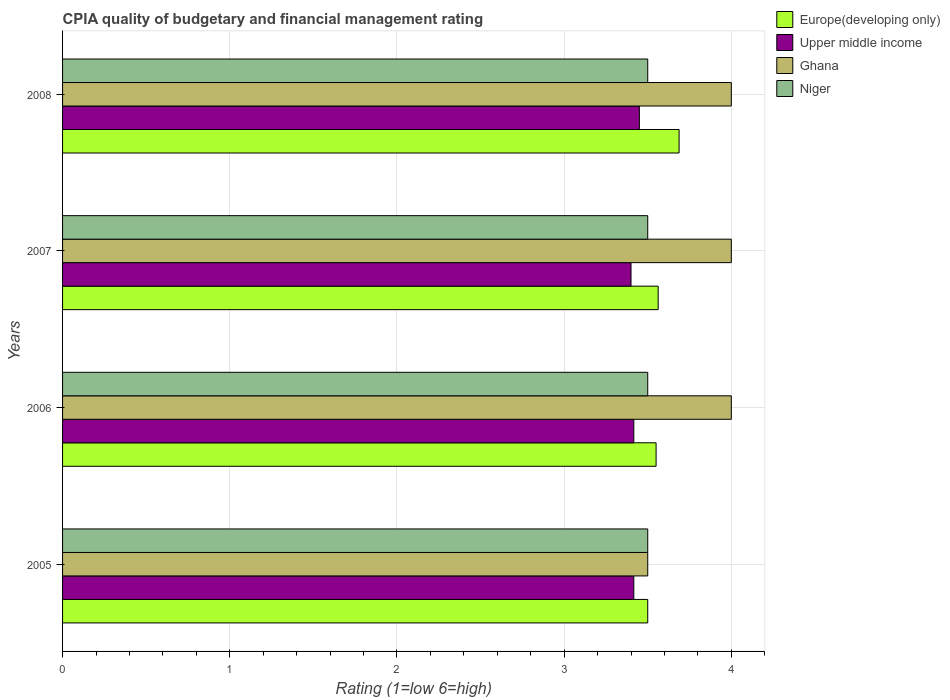How many groups of bars are there?
Give a very brief answer. 4. Are the number of bars on each tick of the Y-axis equal?
Provide a succinct answer. Yes. How many bars are there on the 1st tick from the bottom?
Offer a very short reply. 4. In how many cases, is the number of bars for a given year not equal to the number of legend labels?
Ensure brevity in your answer.  0. What is the CPIA rating in Niger in 2006?
Your response must be concise. 3.5. Across all years, what is the minimum CPIA rating in Upper middle income?
Your answer should be very brief. 3.4. What is the total CPIA rating in Upper middle income in the graph?
Provide a short and direct response. 13.68. What is the difference between the CPIA rating in Ghana in 2006 and the CPIA rating in Upper middle income in 2007?
Your answer should be compact. 0.6. In the year 2007, what is the difference between the CPIA rating in Niger and CPIA rating in Upper middle income?
Your answer should be compact. 0.1. In how many years, is the CPIA rating in Niger greater than 3 ?
Your response must be concise. 4. What is the ratio of the CPIA rating in Europe(developing only) in 2006 to that in 2007?
Ensure brevity in your answer.  1. Is the CPIA rating in Ghana in 2005 less than that in 2008?
Provide a short and direct response. Yes. Is the difference between the CPIA rating in Niger in 2005 and 2008 greater than the difference between the CPIA rating in Upper middle income in 2005 and 2008?
Give a very brief answer. Yes. What is the difference between the highest and the second highest CPIA rating in Upper middle income?
Give a very brief answer. 0.03. What is the difference between the highest and the lowest CPIA rating in Europe(developing only)?
Offer a terse response. 0.19. What does the 4th bar from the top in 2006 represents?
Provide a succinct answer. Europe(developing only). What does the 1st bar from the bottom in 2007 represents?
Your answer should be very brief. Europe(developing only). How many years are there in the graph?
Make the answer very short. 4. What is the difference between two consecutive major ticks on the X-axis?
Provide a succinct answer. 1. Are the values on the major ticks of X-axis written in scientific E-notation?
Your answer should be very brief. No. Does the graph contain grids?
Provide a succinct answer. Yes. Where does the legend appear in the graph?
Provide a short and direct response. Top right. How many legend labels are there?
Offer a terse response. 4. What is the title of the graph?
Provide a succinct answer. CPIA quality of budgetary and financial management rating. What is the Rating (1=low 6=high) in Europe(developing only) in 2005?
Your answer should be compact. 3.5. What is the Rating (1=low 6=high) of Upper middle income in 2005?
Your response must be concise. 3.42. What is the Rating (1=low 6=high) of Europe(developing only) in 2006?
Give a very brief answer. 3.55. What is the Rating (1=low 6=high) of Upper middle income in 2006?
Ensure brevity in your answer.  3.42. What is the Rating (1=low 6=high) of Niger in 2006?
Keep it short and to the point. 3.5. What is the Rating (1=low 6=high) in Europe(developing only) in 2007?
Your response must be concise. 3.56. What is the Rating (1=low 6=high) of Upper middle income in 2007?
Offer a very short reply. 3.4. What is the Rating (1=low 6=high) of Ghana in 2007?
Provide a short and direct response. 4. What is the Rating (1=low 6=high) in Niger in 2007?
Make the answer very short. 3.5. What is the Rating (1=low 6=high) of Europe(developing only) in 2008?
Your response must be concise. 3.69. What is the Rating (1=low 6=high) of Upper middle income in 2008?
Offer a terse response. 3.45. What is the Rating (1=low 6=high) of Ghana in 2008?
Keep it short and to the point. 4. Across all years, what is the maximum Rating (1=low 6=high) in Europe(developing only)?
Your response must be concise. 3.69. Across all years, what is the maximum Rating (1=low 6=high) of Upper middle income?
Offer a very short reply. 3.45. Across all years, what is the minimum Rating (1=low 6=high) of Europe(developing only)?
Offer a terse response. 3.5. Across all years, what is the minimum Rating (1=low 6=high) in Upper middle income?
Offer a very short reply. 3.4. What is the total Rating (1=low 6=high) in Upper middle income in the graph?
Ensure brevity in your answer.  13.68. What is the total Rating (1=low 6=high) of Ghana in the graph?
Provide a succinct answer. 15.5. What is the difference between the Rating (1=low 6=high) of Europe(developing only) in 2005 and that in 2006?
Your answer should be very brief. -0.05. What is the difference between the Rating (1=low 6=high) of Europe(developing only) in 2005 and that in 2007?
Ensure brevity in your answer.  -0.06. What is the difference between the Rating (1=low 6=high) in Upper middle income in 2005 and that in 2007?
Offer a terse response. 0.02. What is the difference between the Rating (1=low 6=high) of Ghana in 2005 and that in 2007?
Keep it short and to the point. -0.5. What is the difference between the Rating (1=low 6=high) in Europe(developing only) in 2005 and that in 2008?
Offer a terse response. -0.19. What is the difference between the Rating (1=low 6=high) in Upper middle income in 2005 and that in 2008?
Your answer should be very brief. -0.03. What is the difference between the Rating (1=low 6=high) in Ghana in 2005 and that in 2008?
Make the answer very short. -0.5. What is the difference between the Rating (1=low 6=high) in Niger in 2005 and that in 2008?
Make the answer very short. 0. What is the difference between the Rating (1=low 6=high) in Europe(developing only) in 2006 and that in 2007?
Your answer should be very brief. -0.01. What is the difference between the Rating (1=low 6=high) of Upper middle income in 2006 and that in 2007?
Your answer should be compact. 0.02. What is the difference between the Rating (1=low 6=high) of Ghana in 2006 and that in 2007?
Make the answer very short. 0. What is the difference between the Rating (1=low 6=high) in Europe(developing only) in 2006 and that in 2008?
Make the answer very short. -0.14. What is the difference between the Rating (1=low 6=high) in Upper middle income in 2006 and that in 2008?
Keep it short and to the point. -0.03. What is the difference between the Rating (1=low 6=high) of Niger in 2006 and that in 2008?
Offer a terse response. 0. What is the difference between the Rating (1=low 6=high) of Europe(developing only) in 2007 and that in 2008?
Offer a very short reply. -0.12. What is the difference between the Rating (1=low 6=high) of Ghana in 2007 and that in 2008?
Give a very brief answer. 0. What is the difference between the Rating (1=low 6=high) in Europe(developing only) in 2005 and the Rating (1=low 6=high) in Upper middle income in 2006?
Your response must be concise. 0.08. What is the difference between the Rating (1=low 6=high) in Europe(developing only) in 2005 and the Rating (1=low 6=high) in Ghana in 2006?
Your answer should be very brief. -0.5. What is the difference between the Rating (1=low 6=high) of Upper middle income in 2005 and the Rating (1=low 6=high) of Ghana in 2006?
Ensure brevity in your answer.  -0.58. What is the difference between the Rating (1=low 6=high) in Upper middle income in 2005 and the Rating (1=low 6=high) in Niger in 2006?
Your response must be concise. -0.08. What is the difference between the Rating (1=low 6=high) in Ghana in 2005 and the Rating (1=low 6=high) in Niger in 2006?
Give a very brief answer. 0. What is the difference between the Rating (1=low 6=high) in Europe(developing only) in 2005 and the Rating (1=low 6=high) in Upper middle income in 2007?
Offer a very short reply. 0.1. What is the difference between the Rating (1=low 6=high) of Upper middle income in 2005 and the Rating (1=low 6=high) of Ghana in 2007?
Ensure brevity in your answer.  -0.58. What is the difference between the Rating (1=low 6=high) in Upper middle income in 2005 and the Rating (1=low 6=high) in Niger in 2007?
Offer a very short reply. -0.08. What is the difference between the Rating (1=low 6=high) of Ghana in 2005 and the Rating (1=low 6=high) of Niger in 2007?
Ensure brevity in your answer.  0. What is the difference between the Rating (1=low 6=high) in Europe(developing only) in 2005 and the Rating (1=low 6=high) in Upper middle income in 2008?
Your answer should be very brief. 0.05. What is the difference between the Rating (1=low 6=high) in Europe(developing only) in 2005 and the Rating (1=low 6=high) in Ghana in 2008?
Offer a very short reply. -0.5. What is the difference between the Rating (1=low 6=high) of Europe(developing only) in 2005 and the Rating (1=low 6=high) of Niger in 2008?
Provide a succinct answer. 0. What is the difference between the Rating (1=low 6=high) in Upper middle income in 2005 and the Rating (1=low 6=high) in Ghana in 2008?
Provide a succinct answer. -0.58. What is the difference between the Rating (1=low 6=high) in Upper middle income in 2005 and the Rating (1=low 6=high) in Niger in 2008?
Offer a terse response. -0.08. What is the difference between the Rating (1=low 6=high) of Ghana in 2005 and the Rating (1=low 6=high) of Niger in 2008?
Offer a terse response. 0. What is the difference between the Rating (1=low 6=high) of Europe(developing only) in 2006 and the Rating (1=low 6=high) of Ghana in 2007?
Your answer should be very brief. -0.45. What is the difference between the Rating (1=low 6=high) in Europe(developing only) in 2006 and the Rating (1=low 6=high) in Niger in 2007?
Keep it short and to the point. 0.05. What is the difference between the Rating (1=low 6=high) in Upper middle income in 2006 and the Rating (1=low 6=high) in Ghana in 2007?
Give a very brief answer. -0.58. What is the difference between the Rating (1=low 6=high) in Upper middle income in 2006 and the Rating (1=low 6=high) in Niger in 2007?
Your response must be concise. -0.08. What is the difference between the Rating (1=low 6=high) in Ghana in 2006 and the Rating (1=low 6=high) in Niger in 2007?
Keep it short and to the point. 0.5. What is the difference between the Rating (1=low 6=high) in Europe(developing only) in 2006 and the Rating (1=low 6=high) in Ghana in 2008?
Ensure brevity in your answer.  -0.45. What is the difference between the Rating (1=low 6=high) in Europe(developing only) in 2006 and the Rating (1=low 6=high) in Niger in 2008?
Your answer should be compact. 0.05. What is the difference between the Rating (1=low 6=high) in Upper middle income in 2006 and the Rating (1=low 6=high) in Ghana in 2008?
Make the answer very short. -0.58. What is the difference between the Rating (1=low 6=high) of Upper middle income in 2006 and the Rating (1=low 6=high) of Niger in 2008?
Your answer should be very brief. -0.08. What is the difference between the Rating (1=low 6=high) of Ghana in 2006 and the Rating (1=low 6=high) of Niger in 2008?
Offer a very short reply. 0.5. What is the difference between the Rating (1=low 6=high) of Europe(developing only) in 2007 and the Rating (1=low 6=high) of Upper middle income in 2008?
Your answer should be compact. 0.11. What is the difference between the Rating (1=low 6=high) of Europe(developing only) in 2007 and the Rating (1=low 6=high) of Ghana in 2008?
Ensure brevity in your answer.  -0.44. What is the difference between the Rating (1=low 6=high) in Europe(developing only) in 2007 and the Rating (1=low 6=high) in Niger in 2008?
Offer a terse response. 0.06. What is the difference between the Rating (1=low 6=high) of Upper middle income in 2007 and the Rating (1=low 6=high) of Ghana in 2008?
Your answer should be very brief. -0.6. What is the difference between the Rating (1=low 6=high) of Upper middle income in 2007 and the Rating (1=low 6=high) of Niger in 2008?
Your response must be concise. -0.1. What is the average Rating (1=low 6=high) of Europe(developing only) per year?
Your answer should be compact. 3.58. What is the average Rating (1=low 6=high) in Upper middle income per year?
Give a very brief answer. 3.42. What is the average Rating (1=low 6=high) of Ghana per year?
Make the answer very short. 3.88. In the year 2005, what is the difference between the Rating (1=low 6=high) in Europe(developing only) and Rating (1=low 6=high) in Upper middle income?
Make the answer very short. 0.08. In the year 2005, what is the difference between the Rating (1=low 6=high) of Europe(developing only) and Rating (1=low 6=high) of Ghana?
Ensure brevity in your answer.  0. In the year 2005, what is the difference between the Rating (1=low 6=high) in Europe(developing only) and Rating (1=low 6=high) in Niger?
Make the answer very short. 0. In the year 2005, what is the difference between the Rating (1=low 6=high) of Upper middle income and Rating (1=low 6=high) of Ghana?
Give a very brief answer. -0.08. In the year 2005, what is the difference between the Rating (1=low 6=high) in Upper middle income and Rating (1=low 6=high) in Niger?
Your response must be concise. -0.08. In the year 2005, what is the difference between the Rating (1=low 6=high) of Ghana and Rating (1=low 6=high) of Niger?
Give a very brief answer. 0. In the year 2006, what is the difference between the Rating (1=low 6=high) in Europe(developing only) and Rating (1=low 6=high) in Upper middle income?
Your response must be concise. 0.13. In the year 2006, what is the difference between the Rating (1=low 6=high) of Europe(developing only) and Rating (1=low 6=high) of Ghana?
Provide a succinct answer. -0.45. In the year 2006, what is the difference between the Rating (1=low 6=high) in Europe(developing only) and Rating (1=low 6=high) in Niger?
Keep it short and to the point. 0.05. In the year 2006, what is the difference between the Rating (1=low 6=high) of Upper middle income and Rating (1=low 6=high) of Ghana?
Your answer should be compact. -0.58. In the year 2006, what is the difference between the Rating (1=low 6=high) in Upper middle income and Rating (1=low 6=high) in Niger?
Your response must be concise. -0.08. In the year 2006, what is the difference between the Rating (1=low 6=high) of Ghana and Rating (1=low 6=high) of Niger?
Give a very brief answer. 0.5. In the year 2007, what is the difference between the Rating (1=low 6=high) of Europe(developing only) and Rating (1=low 6=high) of Upper middle income?
Offer a terse response. 0.16. In the year 2007, what is the difference between the Rating (1=low 6=high) in Europe(developing only) and Rating (1=low 6=high) in Ghana?
Offer a very short reply. -0.44. In the year 2007, what is the difference between the Rating (1=low 6=high) of Europe(developing only) and Rating (1=low 6=high) of Niger?
Your answer should be very brief. 0.06. In the year 2007, what is the difference between the Rating (1=low 6=high) in Upper middle income and Rating (1=low 6=high) in Niger?
Offer a very short reply. -0.1. In the year 2008, what is the difference between the Rating (1=low 6=high) in Europe(developing only) and Rating (1=low 6=high) in Upper middle income?
Keep it short and to the point. 0.24. In the year 2008, what is the difference between the Rating (1=low 6=high) in Europe(developing only) and Rating (1=low 6=high) in Ghana?
Give a very brief answer. -0.31. In the year 2008, what is the difference between the Rating (1=low 6=high) in Europe(developing only) and Rating (1=low 6=high) in Niger?
Provide a short and direct response. 0.19. In the year 2008, what is the difference between the Rating (1=low 6=high) of Upper middle income and Rating (1=low 6=high) of Ghana?
Ensure brevity in your answer.  -0.55. In the year 2008, what is the difference between the Rating (1=low 6=high) of Upper middle income and Rating (1=low 6=high) of Niger?
Offer a terse response. -0.05. What is the ratio of the Rating (1=low 6=high) of Europe(developing only) in 2005 to that in 2006?
Offer a terse response. 0.99. What is the ratio of the Rating (1=low 6=high) of Ghana in 2005 to that in 2006?
Ensure brevity in your answer.  0.88. What is the ratio of the Rating (1=low 6=high) in Niger in 2005 to that in 2006?
Give a very brief answer. 1. What is the ratio of the Rating (1=low 6=high) in Europe(developing only) in 2005 to that in 2007?
Offer a very short reply. 0.98. What is the ratio of the Rating (1=low 6=high) of Upper middle income in 2005 to that in 2007?
Your answer should be compact. 1. What is the ratio of the Rating (1=low 6=high) in Ghana in 2005 to that in 2007?
Ensure brevity in your answer.  0.88. What is the ratio of the Rating (1=low 6=high) of Niger in 2005 to that in 2007?
Your response must be concise. 1. What is the ratio of the Rating (1=low 6=high) in Europe(developing only) in 2005 to that in 2008?
Provide a short and direct response. 0.95. What is the ratio of the Rating (1=low 6=high) of Upper middle income in 2005 to that in 2008?
Give a very brief answer. 0.99. What is the ratio of the Rating (1=low 6=high) of Niger in 2005 to that in 2008?
Give a very brief answer. 1. What is the ratio of the Rating (1=low 6=high) in Ghana in 2006 to that in 2007?
Keep it short and to the point. 1. What is the ratio of the Rating (1=low 6=high) in Niger in 2006 to that in 2007?
Your answer should be compact. 1. What is the ratio of the Rating (1=low 6=high) of Europe(developing only) in 2006 to that in 2008?
Make the answer very short. 0.96. What is the ratio of the Rating (1=low 6=high) of Upper middle income in 2006 to that in 2008?
Give a very brief answer. 0.99. What is the ratio of the Rating (1=low 6=high) of Ghana in 2006 to that in 2008?
Give a very brief answer. 1. What is the ratio of the Rating (1=low 6=high) in Niger in 2006 to that in 2008?
Your answer should be compact. 1. What is the ratio of the Rating (1=low 6=high) of Europe(developing only) in 2007 to that in 2008?
Provide a short and direct response. 0.97. What is the ratio of the Rating (1=low 6=high) in Upper middle income in 2007 to that in 2008?
Offer a very short reply. 0.99. What is the ratio of the Rating (1=low 6=high) of Ghana in 2007 to that in 2008?
Your answer should be very brief. 1. What is the difference between the highest and the second highest Rating (1=low 6=high) in Upper middle income?
Provide a short and direct response. 0.03. What is the difference between the highest and the second highest Rating (1=low 6=high) of Niger?
Your response must be concise. 0. What is the difference between the highest and the lowest Rating (1=low 6=high) in Europe(developing only)?
Give a very brief answer. 0.19. What is the difference between the highest and the lowest Rating (1=low 6=high) in Upper middle income?
Ensure brevity in your answer.  0.05. What is the difference between the highest and the lowest Rating (1=low 6=high) in Ghana?
Your answer should be very brief. 0.5. What is the difference between the highest and the lowest Rating (1=low 6=high) of Niger?
Make the answer very short. 0. 